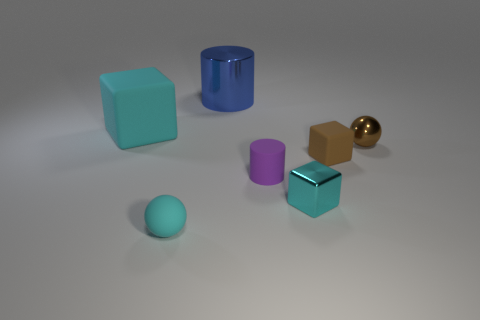There is a shiny sphere; is it the same color as the rubber cube to the right of the blue metallic thing?
Provide a short and direct response. Yes. There is a cylinder that is the same size as the cyan metallic block; what is its material?
Your answer should be compact. Rubber. Are there any purple things that have the same shape as the blue object?
Offer a terse response. Yes. There is a tiny block that is the same color as the big block; what material is it?
Offer a very short reply. Metal. There is a cyan matte object that is behind the cyan sphere; what shape is it?
Your answer should be compact. Cube. How many cyan cylinders are there?
Keep it short and to the point. 0. The cylinder that is the same material as the small cyan ball is what color?
Provide a succinct answer. Purple. What number of small objects are either rubber cubes or cyan blocks?
Offer a terse response. 2. What number of blue things are in front of the tiny purple matte thing?
Provide a succinct answer. 0. What is the color of the other object that is the same shape as the small cyan matte thing?
Your answer should be compact. Brown. 